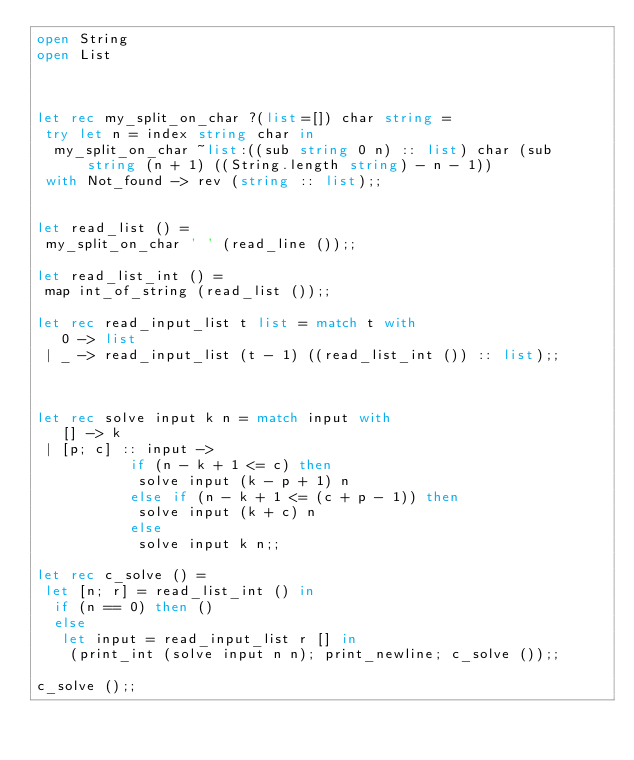Convert code to text. <code><loc_0><loc_0><loc_500><loc_500><_OCaml_>open String
open List



let rec my_split_on_char ?(list=[]) char string =
 try let n = index string char in
  my_split_on_char ~list:((sub string 0 n) :: list) char (sub string (n + 1) ((String.length string) - n - 1))
 with Not_found -> rev (string :: list);;


let read_list () =
 my_split_on_char ' ' (read_line ());;

let read_list_int () =
 map int_of_string (read_list ());;

let rec read_input_list t list = match t with
   0 -> list
 | _ -> read_input_list (t - 1) ((read_list_int ()) :: list);;



let rec solve input k n = match input with
   [] -> k
 | [p; c] :: input ->
           if (n - k + 1 <= c) then
            solve input (k - p + 1) n
           else if (n - k + 1 <= (c + p - 1)) then
            solve input (k + c) n
           else
            solve input k n;;

let rec c_solve () =
 let [n; r] = read_list_int () in
  if (n == 0) then ()
  else
   let input = read_input_list r [] in
    (print_int (solve input n n); print_newline; c_solve ());;

c_solve ();;

</code> 